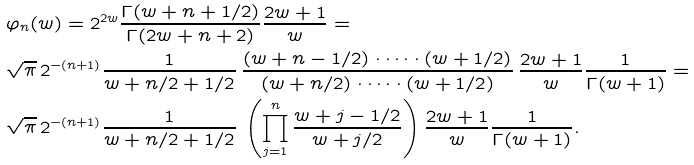<formula> <loc_0><loc_0><loc_500><loc_500>& \varphi _ { n } ( w ) = 2 ^ { 2 w } \frac { \Gamma ( w + n + 1 / 2 ) } { \Gamma ( 2 w + n + 2 ) } \frac { 2 w + 1 } { w } = \\ & \sqrt { \pi } \, 2 ^ { - ( n + 1 ) } \frac { 1 } { w + n / 2 + 1 / 2 } \, \frac { ( w + n - 1 / 2 ) \cdot \dots \cdot ( w + 1 / 2 ) } { ( w + n / 2 ) \cdot \dots \cdot ( w + 1 / 2 ) } \, \frac { 2 w + 1 } { w } \frac { 1 } { \Gamma ( w + 1 ) } = \\ & \sqrt { \pi } \, 2 ^ { - ( n + 1 ) } \frac { 1 } { w + n / 2 + 1 / 2 } \, \left ( \prod _ { j = 1 } ^ { n } \frac { w + j - 1 / 2 } { w + j / 2 } \right ) \frac { 2 w + 1 } { w } \frac { 1 } { \Gamma ( w + 1 ) } .</formula> 